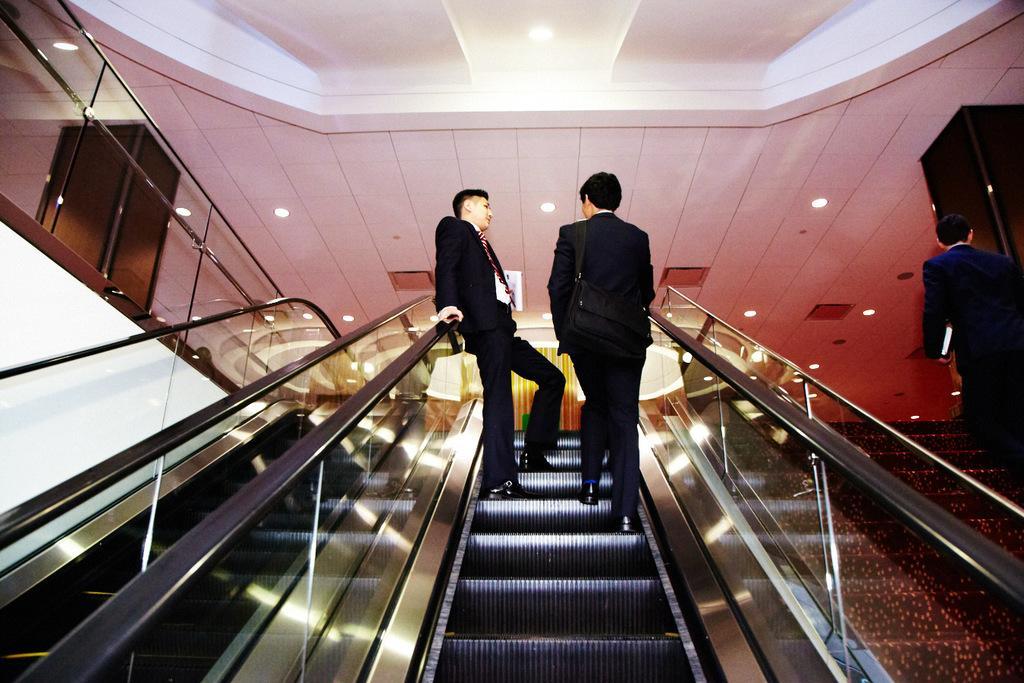Could you give a brief overview of what you see in this image? In this image I can see escalators, stairs and on it I can three persons. I can also see all of them are wearing formal dress and one of them is carrying a bag. On the both sides of the image I can see railings and in the background I can see number of lights on the ceiling. 